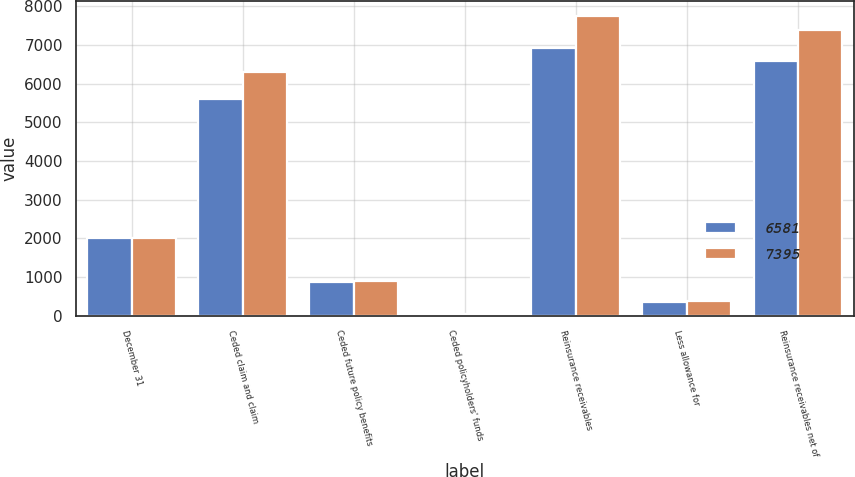<chart> <loc_0><loc_0><loc_500><loc_500><stacked_bar_chart><ecel><fcel>December 31<fcel>Ceded claim and claim<fcel>Ceded future policy benefits<fcel>Ceded policyholders' funds<fcel>Reinsurance receivables<fcel>Less allowance for<fcel>Reinsurance receivables net of<nl><fcel>6581<fcel>2009<fcel>5594<fcel>859<fcel>39<fcel>6932<fcel>351<fcel>6581<nl><fcel>7395<fcel>2008<fcel>6288<fcel>903<fcel>39<fcel>7761<fcel>366<fcel>7395<nl></chart> 